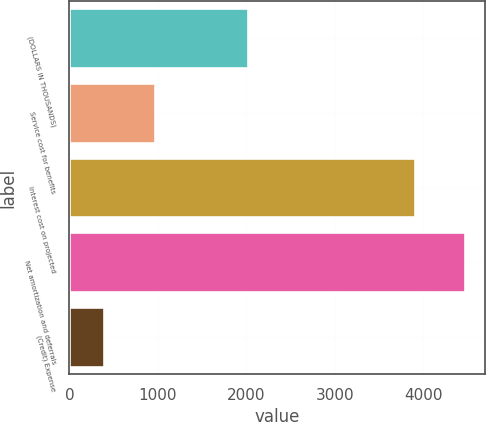<chart> <loc_0><loc_0><loc_500><loc_500><bar_chart><fcel>(DOLLARS IN THOUSANDS)<fcel>Service cost for benefits<fcel>Interest cost on projected<fcel>Net amortization and deferrals<fcel>(Credit) Expense<nl><fcel>2015<fcel>966<fcel>3904<fcel>4476<fcel>394<nl></chart> 